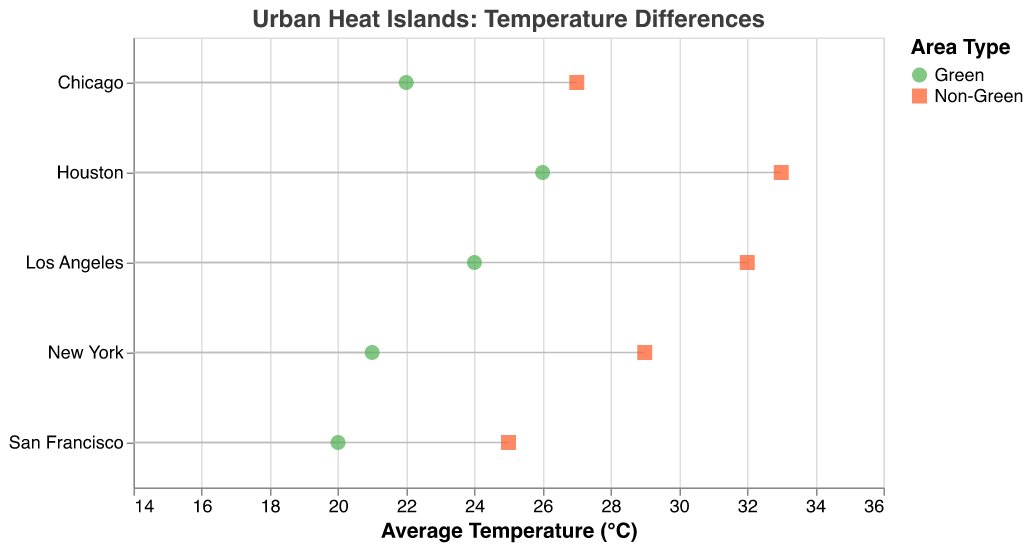What is the average temperature in Midtown Manhattan? The plot shows the average temperatures for different areas within each city. For New York, the data point for Midtown Manhattan indicates an average temperature of 29°C.
Answer: 29°C Which city has the largest temperature difference between its green and non-green areas? To determine the city with the largest temperature difference, compare the differences between the green and non-green areas for each city. San Francisco (25-20=5°C), Chicago (27-22=5°C), New York (29-21=8°C), Los Angeles (32-24=8°C), Houston (33-26=7°C). New York and Los Angeles have the largest differences, both at 8°C.
Answer: New York and Los Angeles What is the average temperature difference between green and non-green areas across all cities? Calculate the difference for each city and then average them: San Francisco (5), Chicago (5), New York (8), Los Angeles (8), Houston (7). The sum is 5+5+8+8+7=33, and the average temperature difference is 33/5 = 6.6°C.
Answer: 6.6°C Which city has the lowest average temperature in its green area? The green areas are: San Francisco (Golden Gate Park 20°C), Chicago (Lincoln Park 22°C), New York (Central Park 21°C), Los Angeles (Griffith Park 24°C), Houston (Hermann Park 26°C). The lowest average temperature in green areas is Golden Gate Park in San Francisco with 20°C.
Answer: San Francisco How much higher is the temperature in Downtown Houston compared to Hermann Park in Houston? The plot shows that Hermann Park in Houston has an average temperature of 26°C, and Downtown Houston has 33°C. The difference is 33 - 26 = 7°C.
Answer: 7°C Which city's non-green area has the highest average temperature? The non-green areas are: San Francisco (Financial District 25°C), Chicago (The Loop 27°C), New York (Midtown Manhattan 29°C), Los Angeles (Downtown LA 32°C), Houston (Downtown Houston 33°C). The highest average temperature in non-green areas is Downtown Houston with 33°C.
Answer: Houston What is the title of the figure? The title is typically located at the top or designated position in the visual. In this case, it is "Urban Heat Islands: Temperature Differences."
Answer: Urban Heat Islands: Temperature Differences Compare the average temperatures of the green and non-green areas in Chicago. For Chicago, the green area (Lincoln Park) has an average temperature of 22°C, and the non-green area (The Loop) has 27°C. Thus, the non-green area is 5°C hotter than the green area.
Answer: Non-green area is 5°C hotter Identify which city shows the smallest difference in temperature between its green and non-green areas. Compare the differences: San Francisco (5°C), Chicago (5°C), New York (8°C), Los Angeles (8°C), Houston (7°C). San Francisco and Chicago both show the smallest difference of 5°C.
Answer: San Francisco and Chicago What is the range of average temperatures depicted in the figure? Review the minimum and maximum values on the x-axis, which show average temperatures ranging from 15°C to 35°C. Based on the data points, the actual range is from the lowest value 20°C (Golden Gate Park) to the highest value 33°C (Downtown Houston).
Answer: 20°C to 33°C 